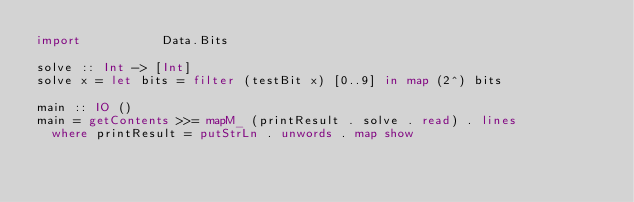Convert code to text. <code><loc_0><loc_0><loc_500><loc_500><_Haskell_>import           Data.Bits

solve :: Int -> [Int]
solve x = let bits = filter (testBit x) [0..9] in map (2^) bits

main :: IO ()
main = getContents >>= mapM_ (printResult . solve . read) . lines
  where printResult = putStrLn . unwords . map show</code> 